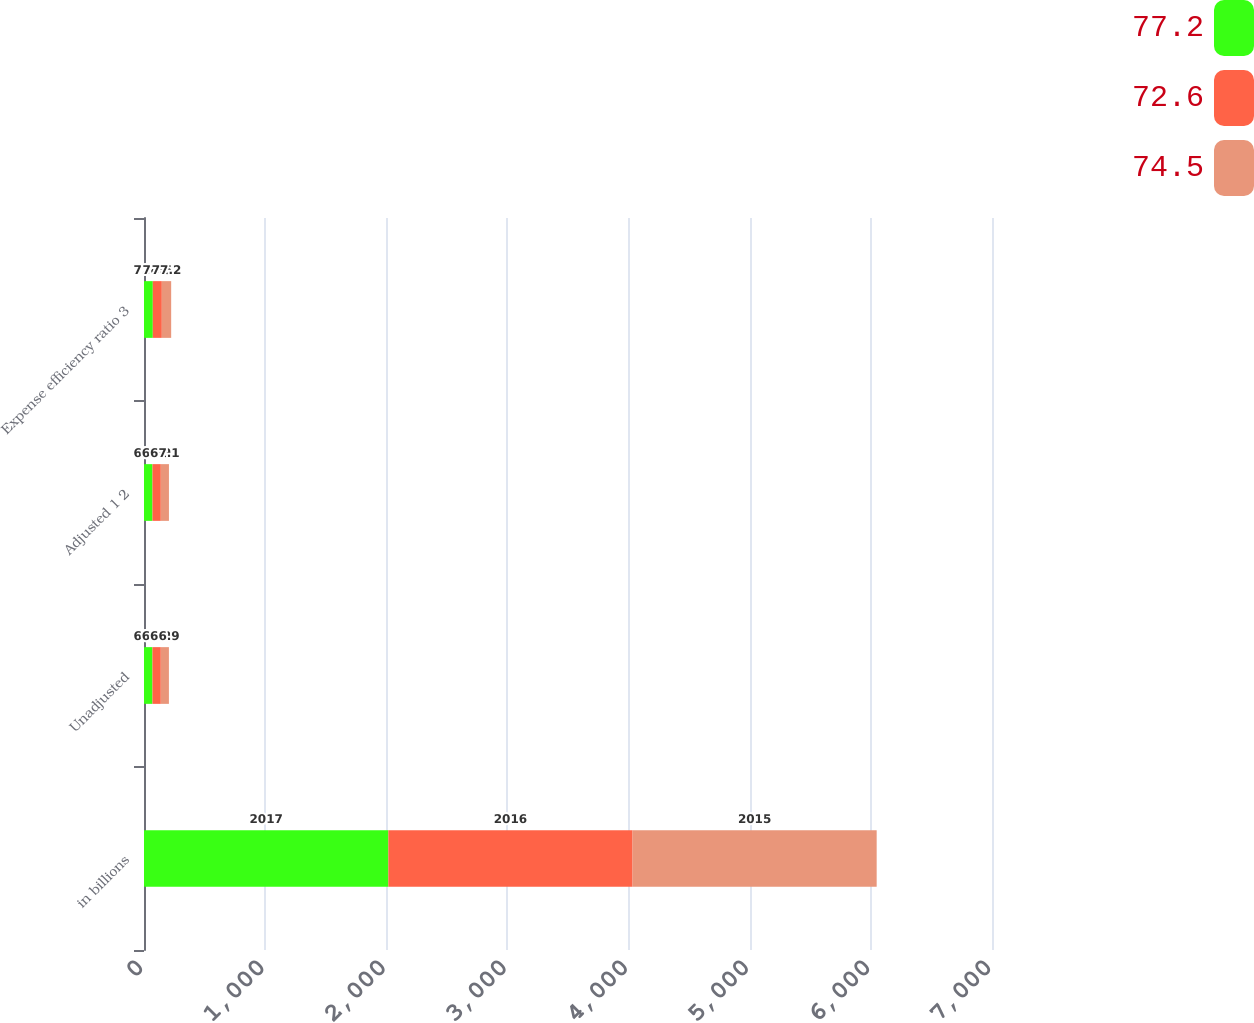Convert chart to OTSL. <chart><loc_0><loc_0><loc_500><loc_500><stacked_bar_chart><ecel><fcel>in billions<fcel>Unadjusted<fcel>Adjusted 1 2<fcel>Expense efficiency ratio 3<nl><fcel>77.2<fcel>2017<fcel>69.8<fcel>69.9<fcel>72.6<nl><fcel>72.6<fcel>2016<fcel>68.9<fcel>68.9<fcel>74.5<nl><fcel>74.5<fcel>2015<fcel>66.9<fcel>67.1<fcel>77.2<nl></chart> 